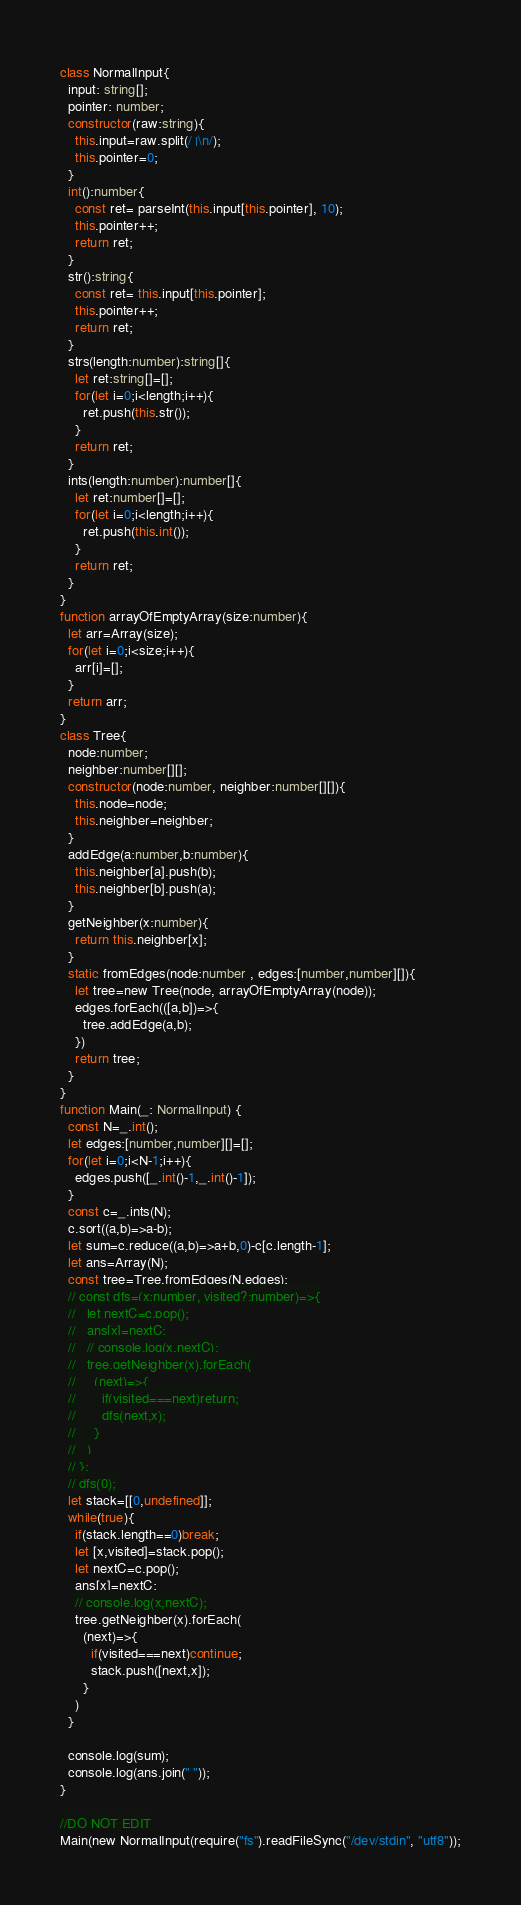<code> <loc_0><loc_0><loc_500><loc_500><_TypeScript_>class NormalInput{
  input: string[];
  pointer: number;
  constructor(raw:string){
    this.input=raw.split(/ |\n/);
    this.pointer=0;
  }
  int():number{
    const ret= parseInt(this.input[this.pointer], 10);
    this.pointer++;
    return ret;
  }
  str():string{
    const ret= this.input[this.pointer];
    this.pointer++;
    return ret;
  }
  strs(length:number):string[]{
    let ret:string[]=[];
    for(let i=0;i<length;i++){
      ret.push(this.str());
    }
    return ret;
  }
  ints(length:number):number[]{
    let ret:number[]=[];
    for(let i=0;i<length;i++){
      ret.push(this.int());
    }
    return ret;
  }
}
function arrayOfEmptyArray(size:number){
  let arr=Array(size);
  for(let i=0;i<size;i++){
    arr[i]=[];
  }
  return arr;
}
class Tree{
  node:number;
  neighber:number[][];
  constructor(node:number, neighber:number[][]){
    this.node=node;
    this.neighber=neighber;
  }
  addEdge(a:number,b:number){
    this.neighber[a].push(b);
    this.neighber[b].push(a);
  }
  getNeighber(x:number){
    return this.neighber[x];
  }
  static fromEdges(node:number , edges:[number,number][]){
    let tree=new Tree(node, arrayOfEmptyArray(node));
    edges.forEach(([a,b])=>{
      tree.addEdge(a,b);
    })
    return tree;
  }
}
function Main(_: NormalInput) {
  const N=_.int();
  let edges:[number,number][]=[];
  for(let i=0;i<N-1;i++){
    edges.push([_.int()-1,_.int()-1]);
  }
  const c=_.ints(N);
  c.sort((a,b)=>a-b);
  let sum=c.reduce((a,b)=>a+b,0)-c[c.length-1];
  let ans=Array(N);
  const tree=Tree.fromEdges(N,edges);
  // const dfs=(x:number, visited?:number)=>{
  //   let nextC=c.pop();
  //   ans[x]=nextC;
  //   // console.log(x,nextC);
  //   tree.getNeighber(x).forEach(
  //     (next)=>{
  //       if(visited===next)return;
  //       dfs(next,x);
  //     }
  //   )
  // };
  // dfs(0);
  let stack=[[0,undefined]];
  while(true){
    if(stack.length==0)break;
    let [x,visited]=stack.pop();
    let nextC=c.pop();
    ans[x]=nextC;
    // console.log(x,nextC);
    tree.getNeighber(x).forEach(
      (next)=>{
        if(visited===next)continue;
        stack.push([next,x]);
      }
    )
  }
  
  console.log(sum);
  console.log(ans.join(" "));
}

//DO NOT EDIT
Main(new NormalInput(require("fs").readFileSync("/dev/stdin", "utf8"));
</code> 